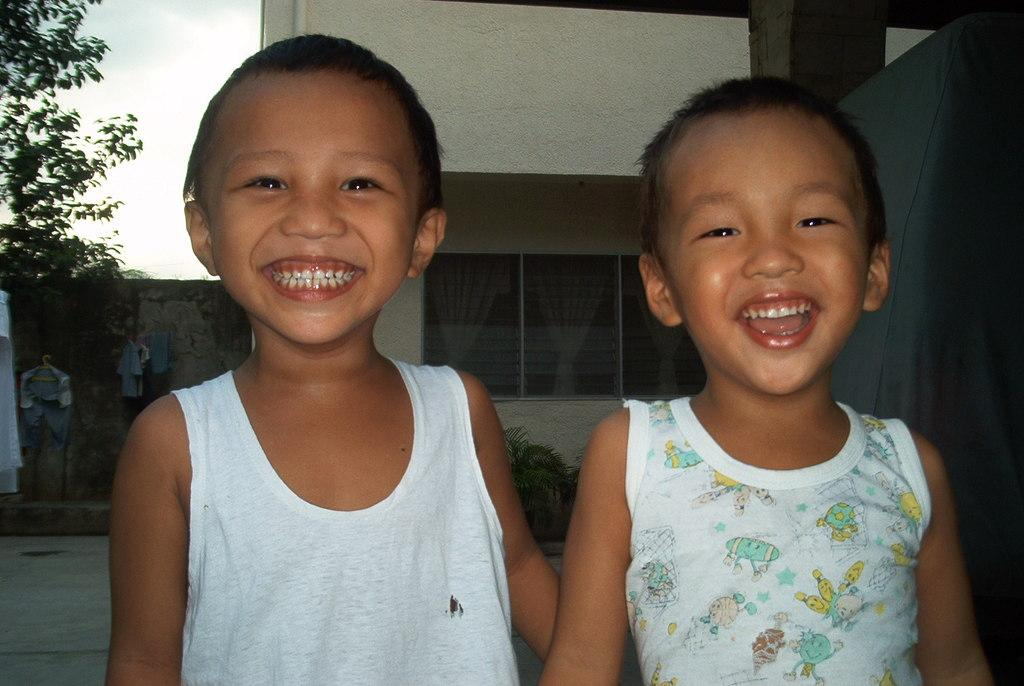How many children are in the image? There are two children in the image. What is the facial expression of the children? The children are smiling. What can be seen in the background of the image? There is a building, curtains, trees, plants, a wall, and the sky visible in the background of the image. Can you see a woman in the image? No, there is no woman present in the image. --- Facts: 1. There is a car in the image. 2. The car is red. 3. The car has four wheels. 4. There are people inside the car. 5. The car has a sunroof. 6. The car is parked on the street. Absurd Topics: elephant Conversation: What is the main subject in the image? The main subject in the image is a car. What color is the car? The car is red. How many wheels does the car have? The car has four wheels. Are there any people inside the car? Yes, there are people inside the car. What is a unique feature of the car? The car has a sunroof. Where is the car located in the image? The car is parked on the street. Reasoning: Let's think step by step in order to produce the conversation. We start by identifying the main subject of the image, which is the car. Next, we describe specific features of the car, such as its color, the number of wheels, and the presence of a sunroof. Then, we observe the actions of the people inside the car. Finally, we describe the location of the car in the image, which is parked on the street. Absurd Question/Answer: How many elephants can be seen standing next to the car in the image? There are no elephants present in the image. --- Facts: 1. There is a dog in the image. 2. The dog is brown. 3. The dog is wagging its tail. 4. There is a leash attached to the dog's collar. 5. The dog is sitting next to a tree. Absurd Topics: spaceship Conversation: What type of animal is in the image? There is a dog in the image. What color is the dog? The dog is brown. What is the dog doing in the image? The dog is wagging its tail. Is the dog attached to anything in the image? Yes, there is a leash attached to the dog's collar. Where is the dog located in the image? The dog is sitting next to a tree. Reasoning: Let's think step by step in order to produce the conversation. We start by identifying the main subject of the image, which is the dog. Next, we describe specific features of the dog, such as its color and the fact that it is w 